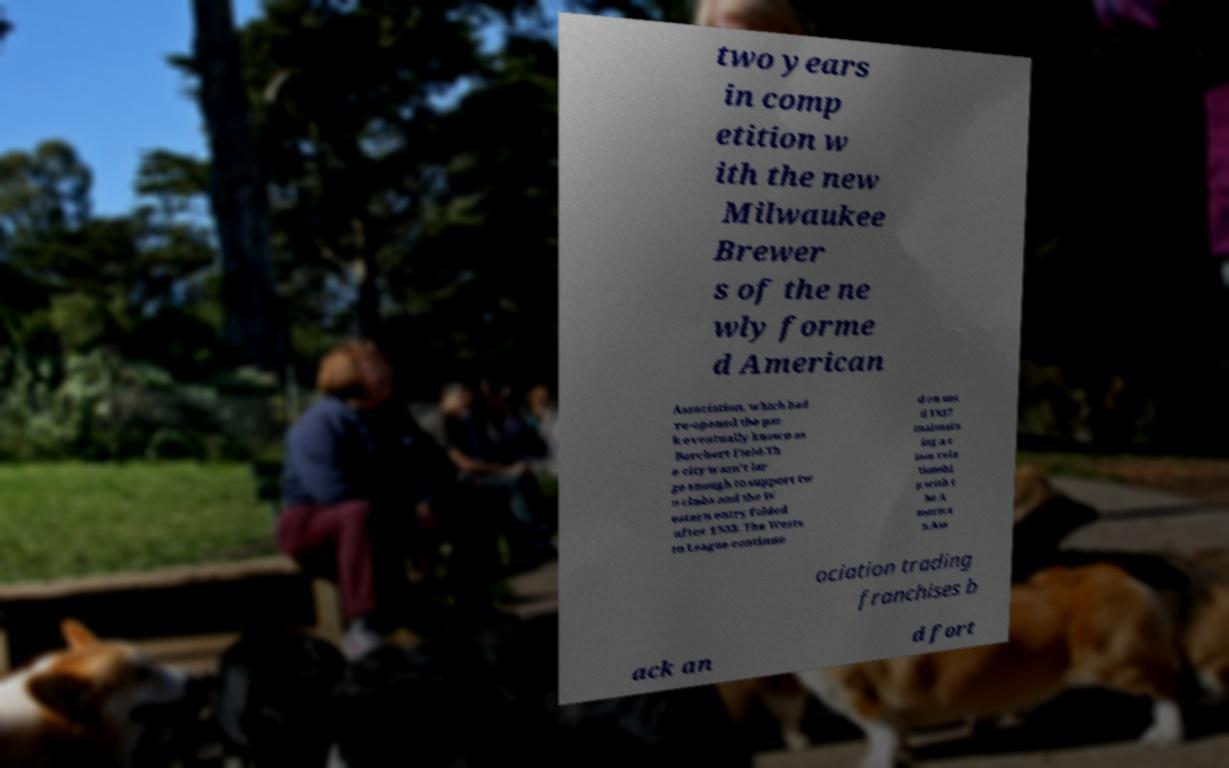There's text embedded in this image that I need extracted. Can you transcribe it verbatim? two years in comp etition w ith the new Milwaukee Brewer s of the ne wly forme d American Association, which had re-opened the par k eventually known as Borchert Field.Th e city wasn't lar ge enough to support tw o clubs and the W estern entry folded after 1903. The Weste rn League continue d on unt il 1937 maintain ing a c lose rela tionshi p with t he A merica n Ass ociation trading franchises b ack an d fort 